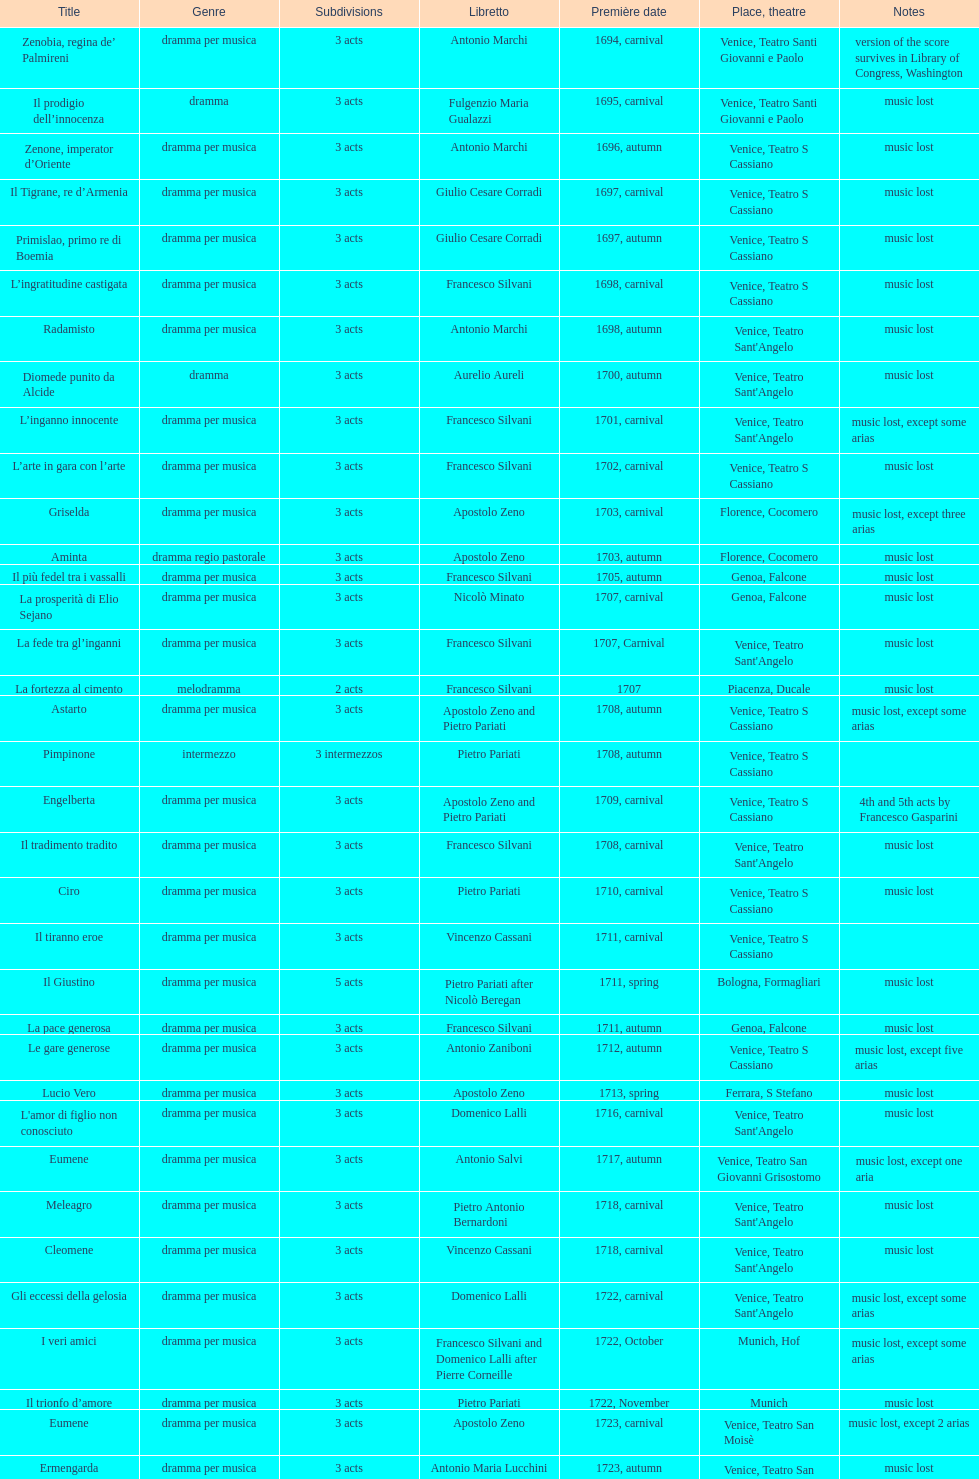After zenone, imperator d'oriente, what was the number of releases? 52. 